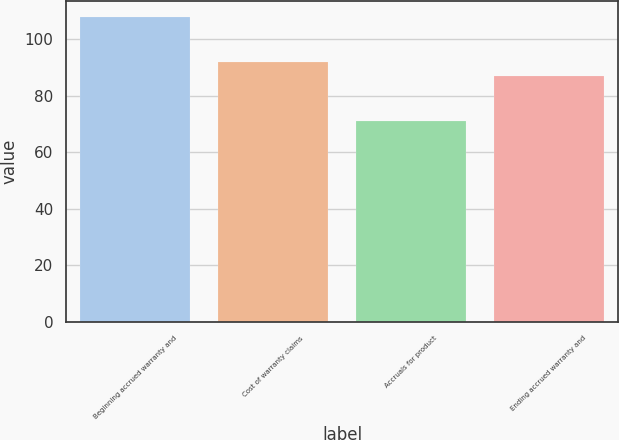<chart> <loc_0><loc_0><loc_500><loc_500><bar_chart><fcel>Beginning accrued warranty and<fcel>Cost of warranty claims<fcel>Accruals for product<fcel>Ending accrued warranty and<nl><fcel>108<fcel>92<fcel>71<fcel>87<nl></chart> 